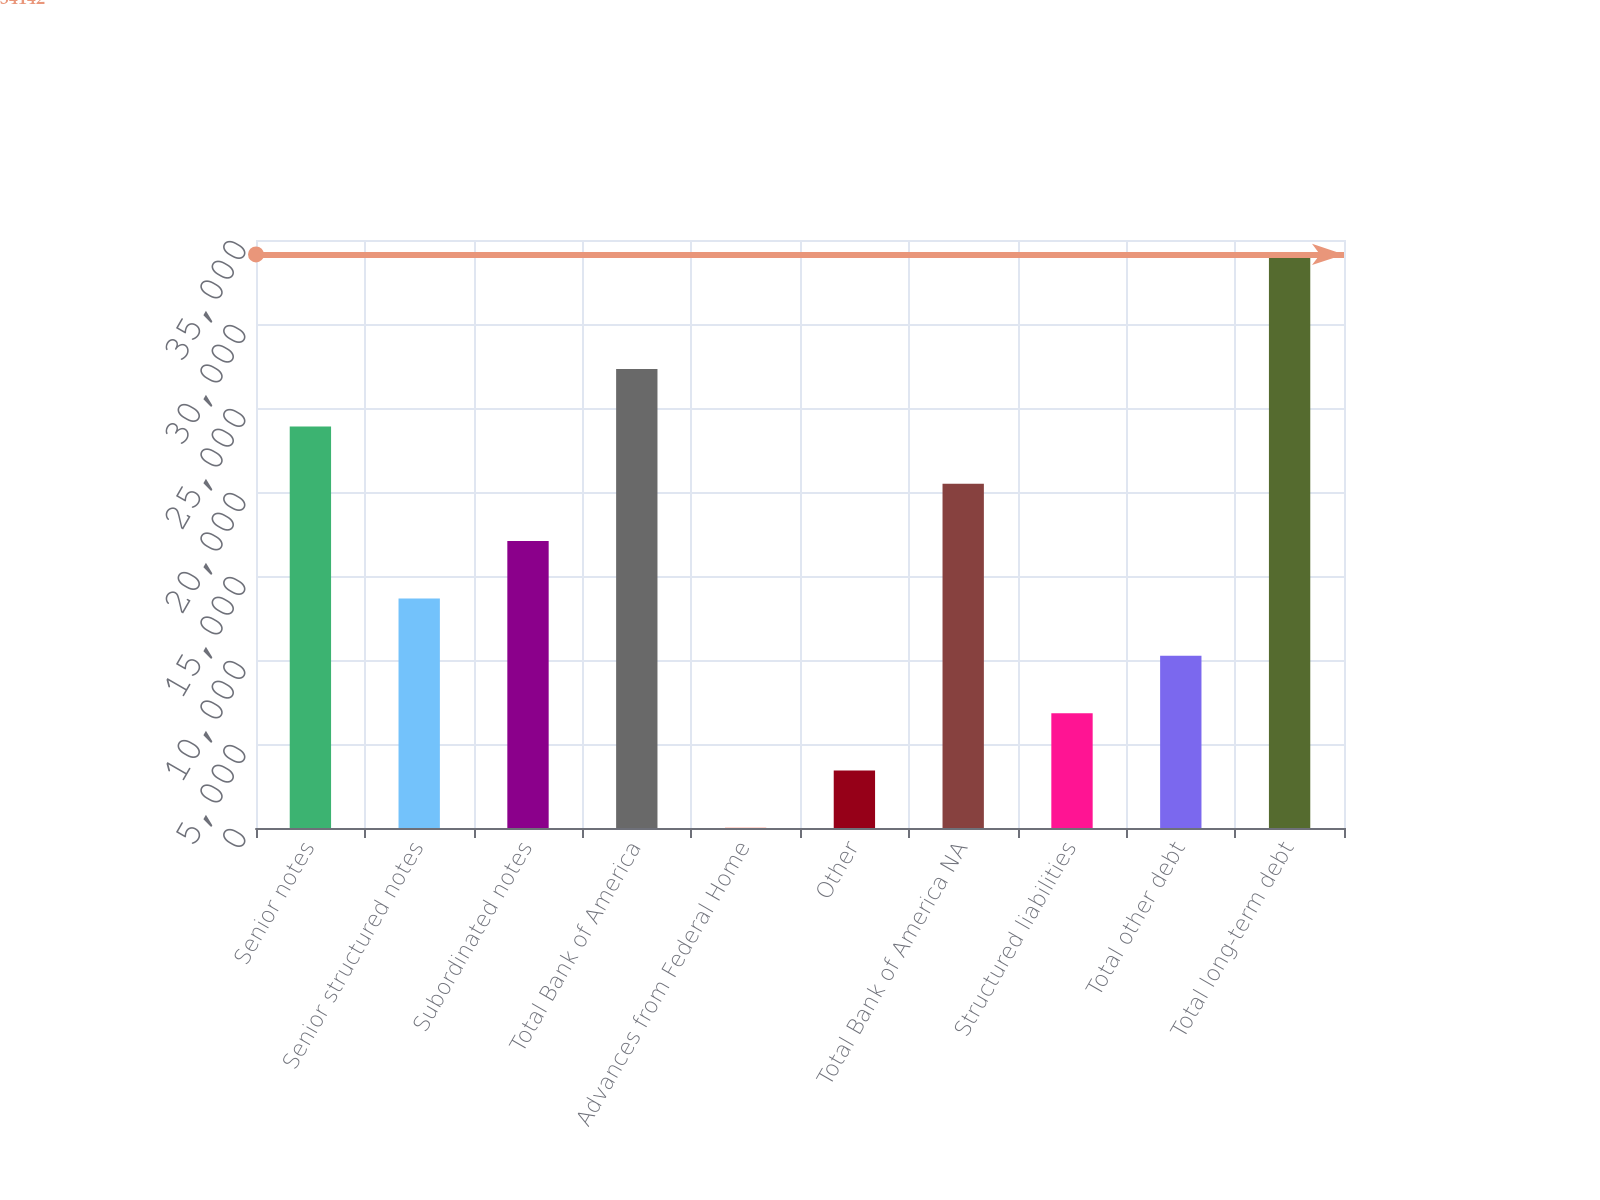<chart> <loc_0><loc_0><loc_500><loc_500><bar_chart><fcel>Senior notes<fcel>Senior structured notes<fcel>Subordinated notes<fcel>Total Bank of America<fcel>Advances from Federal Home<fcel>Other<fcel>Total Bank of America NA<fcel>Structured liabilities<fcel>Total other debt<fcel>Total long-term debt<nl><fcel>23902.4<fcel>13662.8<fcel>17076<fcel>27315.6<fcel>10<fcel>3423.2<fcel>20489.2<fcel>6836.4<fcel>10249.6<fcel>34142<nl></chart> 